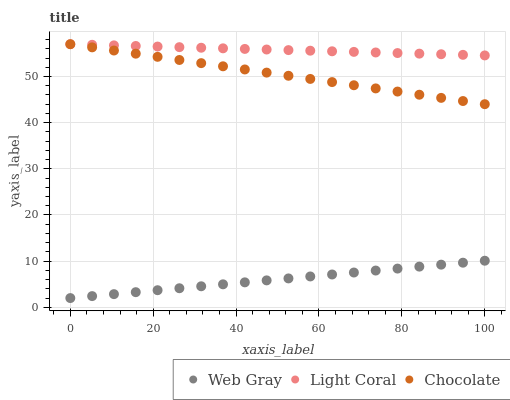Does Web Gray have the minimum area under the curve?
Answer yes or no. Yes. Does Light Coral have the maximum area under the curve?
Answer yes or no. Yes. Does Chocolate have the minimum area under the curve?
Answer yes or no. No. Does Chocolate have the maximum area under the curve?
Answer yes or no. No. Is Web Gray the smoothest?
Answer yes or no. Yes. Is Light Coral the roughest?
Answer yes or no. Yes. Is Chocolate the smoothest?
Answer yes or no. No. Is Chocolate the roughest?
Answer yes or no. No. Does Web Gray have the lowest value?
Answer yes or no. Yes. Does Chocolate have the lowest value?
Answer yes or no. No. Does Chocolate have the highest value?
Answer yes or no. Yes. Does Web Gray have the highest value?
Answer yes or no. No. Is Web Gray less than Light Coral?
Answer yes or no. Yes. Is Light Coral greater than Web Gray?
Answer yes or no. Yes. Does Light Coral intersect Chocolate?
Answer yes or no. Yes. Is Light Coral less than Chocolate?
Answer yes or no. No. Is Light Coral greater than Chocolate?
Answer yes or no. No. Does Web Gray intersect Light Coral?
Answer yes or no. No. 